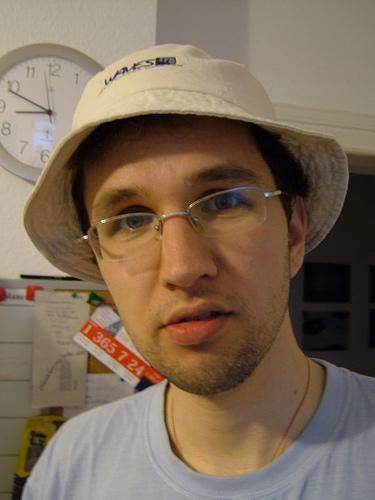How many school buses are shown?
Give a very brief answer. 0. 